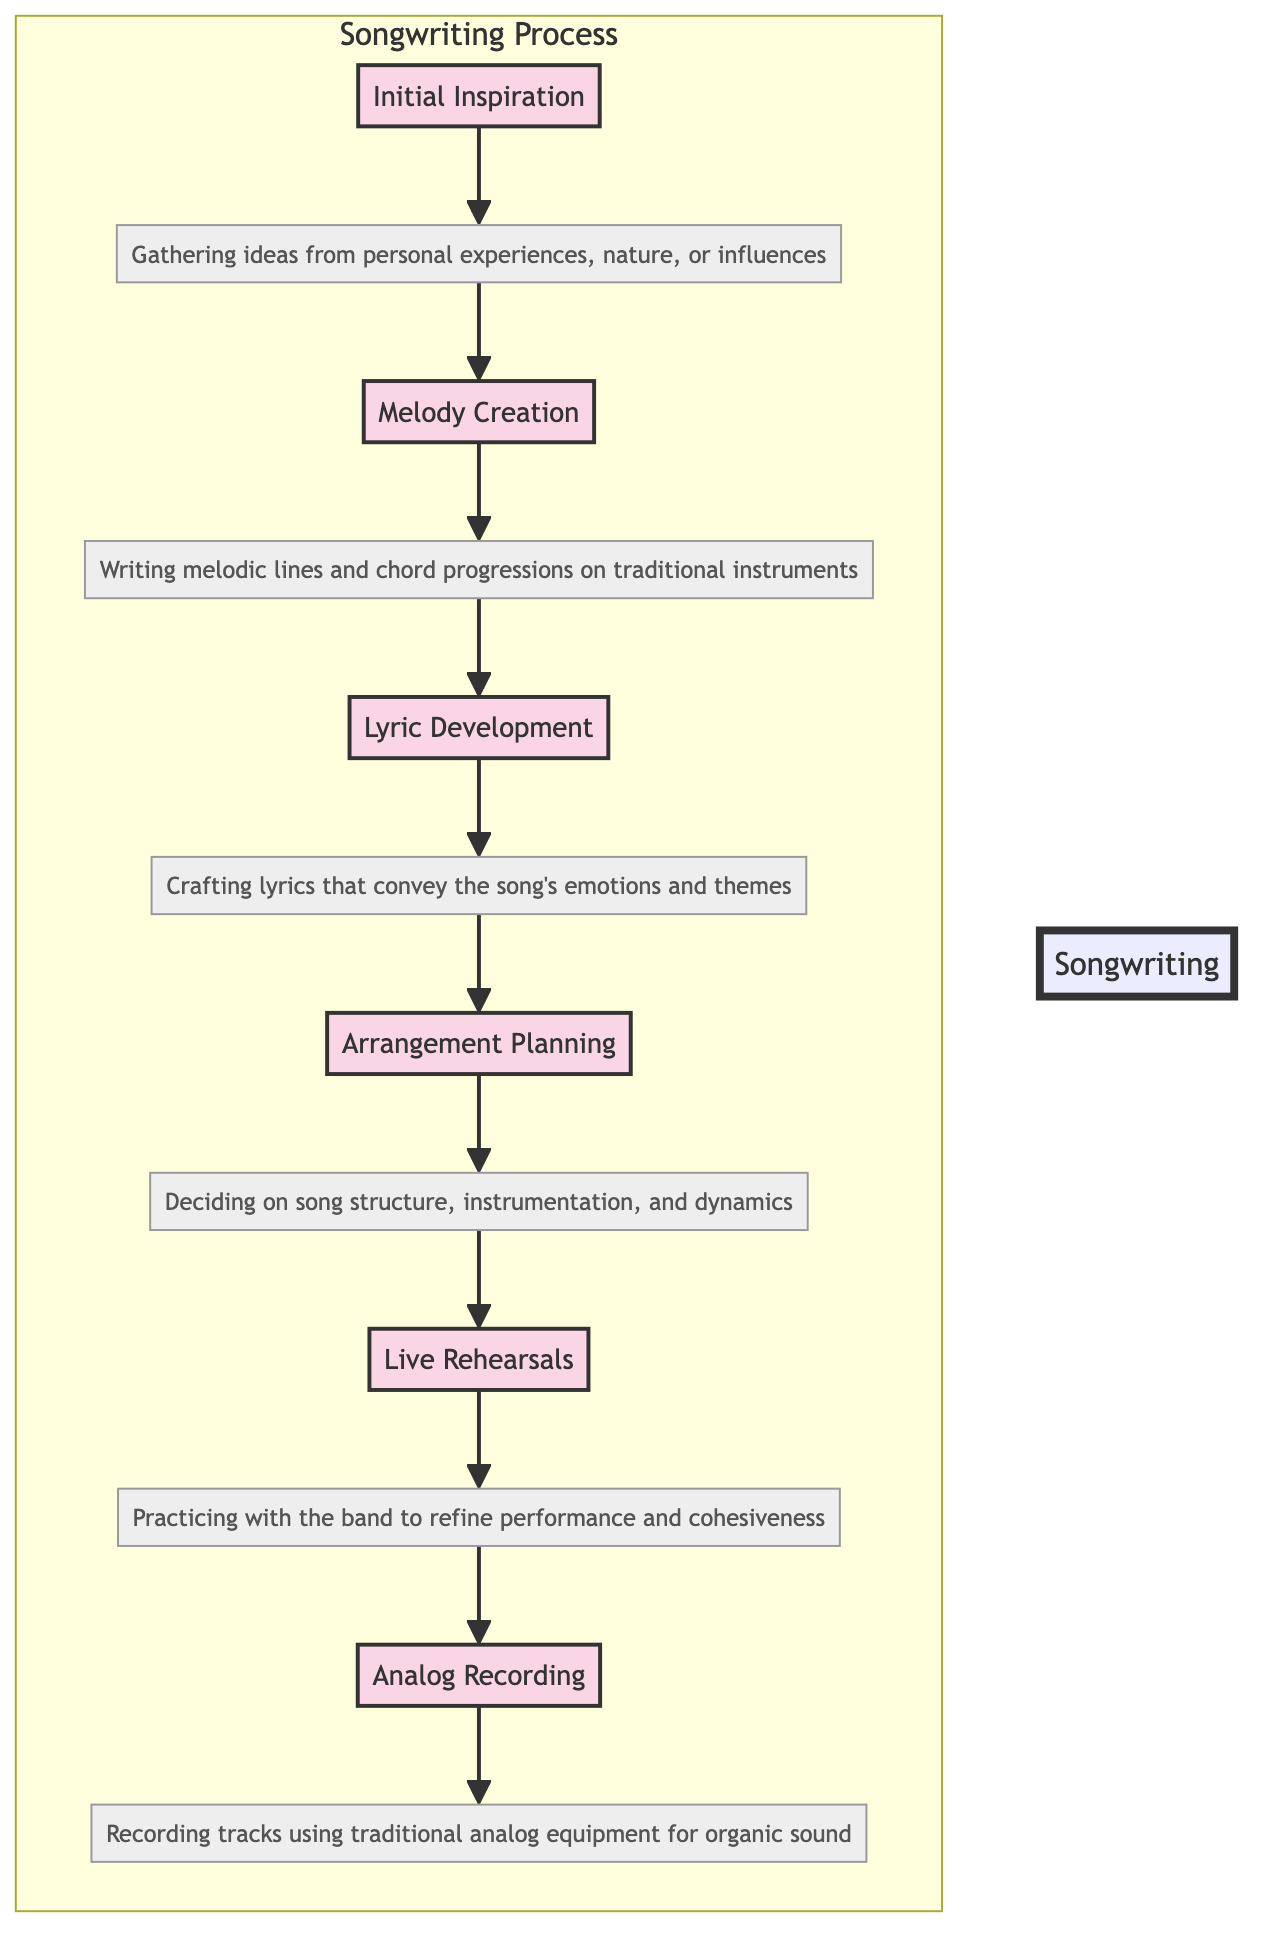What is the first stage in the songwriting process? The diagram indicates that the first stage is "Initial Inspiration." This is the first node listed in the flowchart, starting the process of songwriting.
Answer: Initial Inspiration How many stages are in the songwriting process? By counting the stages listed in the diagram, it can be seen that there are six stages present in total.
Answer: 6 Which stage follows "Lyric Development"? The diagram shows that "Arrangement Planning" directly follows "Lyric Development," as indicated by the arrow pointing from C to D.
Answer: Arrangement Planning What is the description for "Live Rehearsals"? The description from the diagram states that "Live Rehearsals" involves "Practicing the song with the band to refine performance and cohesiveness." This is how the process is detailed in the flowchart.
Answer: Practicing the song with the band to refine performance and cohesiveness Which stage leads to "Analog Recording"? The diagram illustrates that "Live Rehearsals" leads to "Analog Recording." This is observed through the directional flow from E to F.
Answer: Live Rehearsals Describe the relationship between "Melody Creation" and "Initial Inspiration." The relationship is one of sequence; "Initial Inspiration" provides the ideas needed to begin "Melody Creation." This can be traced through the flowchart since A leads to B.
Answer: Initial Inspiration provides ideas for Melody Creation Which stage focuses on capturing an organic sound? The "Analog Recording" stage is focused on capturing an organic sound, as described in the flowchart's respective node.
Answer: Analog Recording What is the final stage in the songwriting process? The diagram clearly shows that the final stage is "Analog Recording," which is placed at the bottom of the flowchart and follows all other stages.
Answer: Analog Recording What are the direct precedents to "Arrangement Planning"? The direct precedents to "Arrangement Planning" are "Lyric Development" and "Melody Creation," since both stages must occur before it as indicated by the directional flow.
Answer: Melody Creation, Lyric Development 